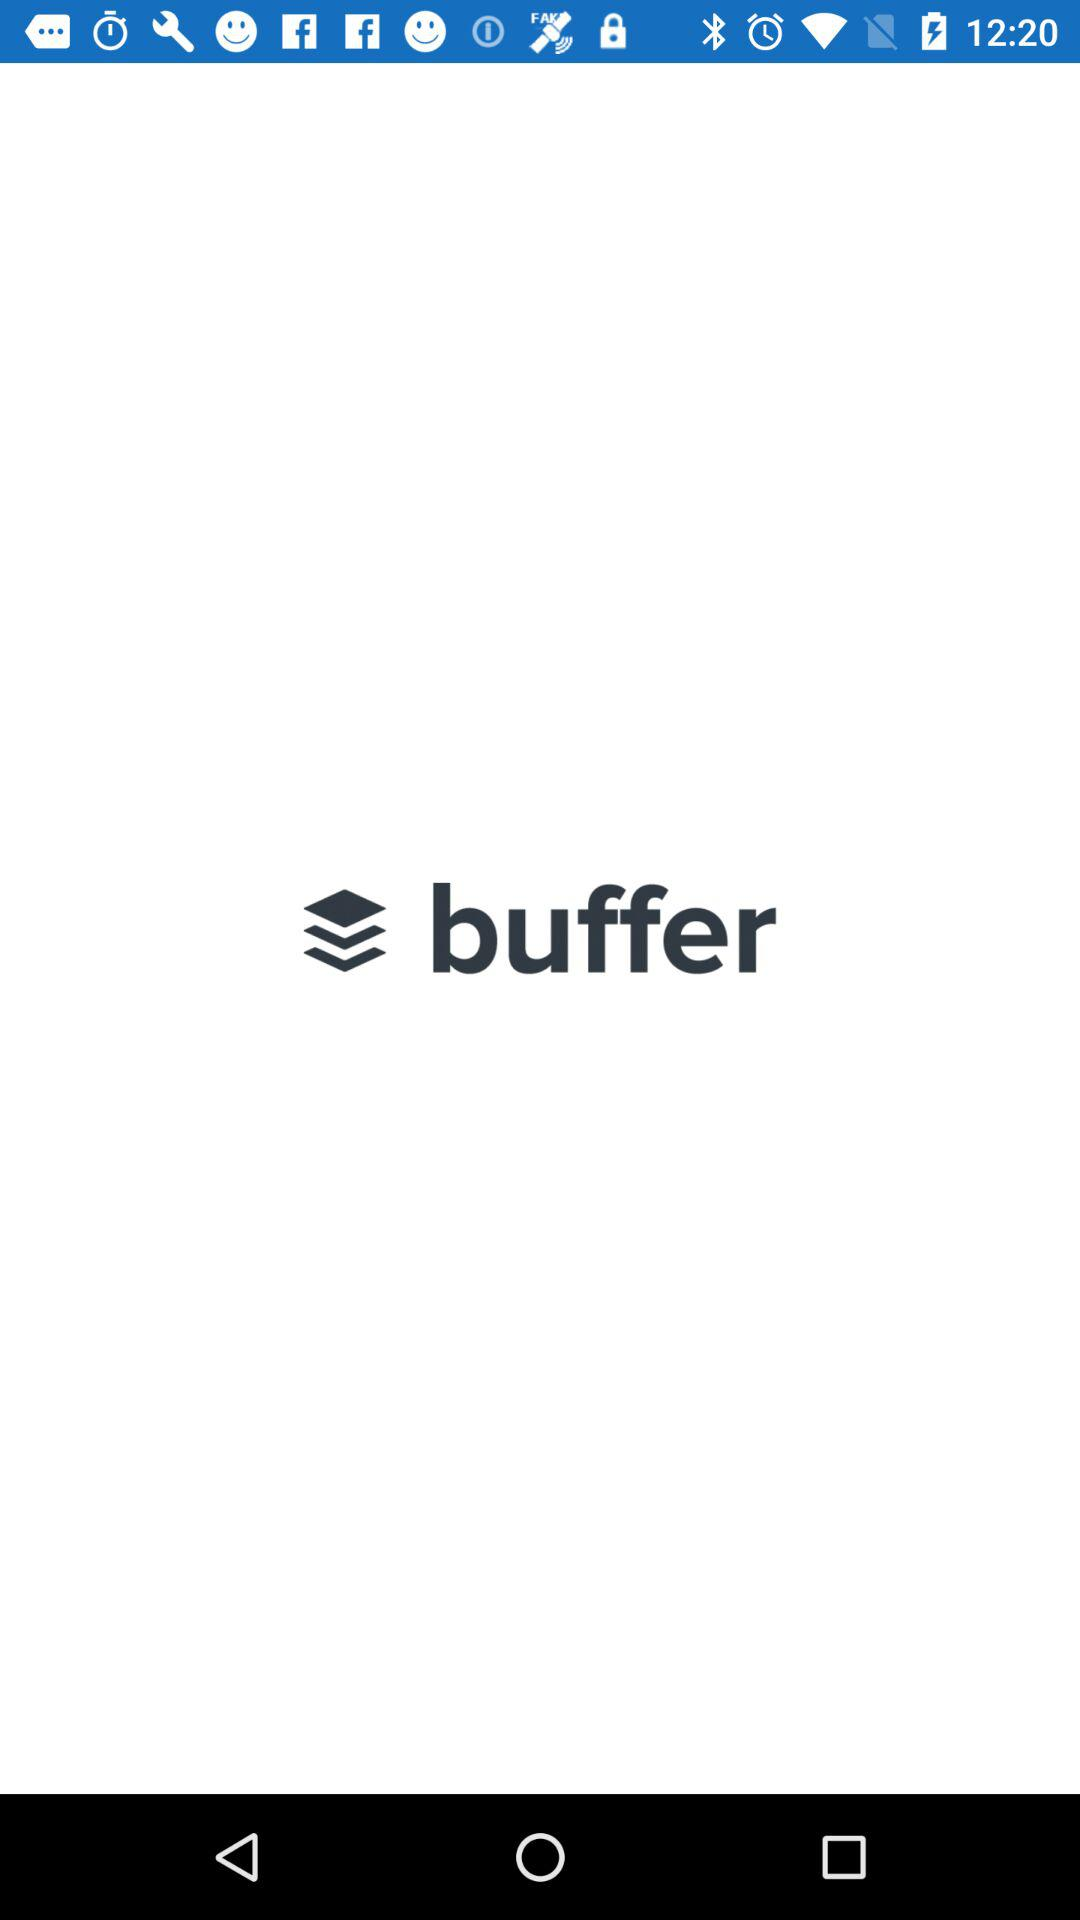What is the name of the application? The name of the application is "buffer". 